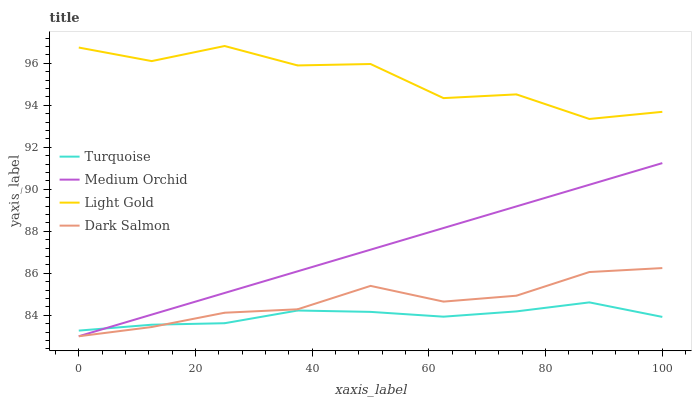Does Turquoise have the minimum area under the curve?
Answer yes or no. Yes. Does Light Gold have the maximum area under the curve?
Answer yes or no. Yes. Does Medium Orchid have the minimum area under the curve?
Answer yes or no. No. Does Medium Orchid have the maximum area under the curve?
Answer yes or no. No. Is Medium Orchid the smoothest?
Answer yes or no. Yes. Is Light Gold the roughest?
Answer yes or no. Yes. Is Light Gold the smoothest?
Answer yes or no. No. Is Medium Orchid the roughest?
Answer yes or no. No. Does Medium Orchid have the lowest value?
Answer yes or no. Yes. Does Light Gold have the lowest value?
Answer yes or no. No. Does Light Gold have the highest value?
Answer yes or no. Yes. Does Medium Orchid have the highest value?
Answer yes or no. No. Is Dark Salmon less than Light Gold?
Answer yes or no. Yes. Is Light Gold greater than Medium Orchid?
Answer yes or no. Yes. Does Turquoise intersect Medium Orchid?
Answer yes or no. Yes. Is Turquoise less than Medium Orchid?
Answer yes or no. No. Is Turquoise greater than Medium Orchid?
Answer yes or no. No. Does Dark Salmon intersect Light Gold?
Answer yes or no. No. 